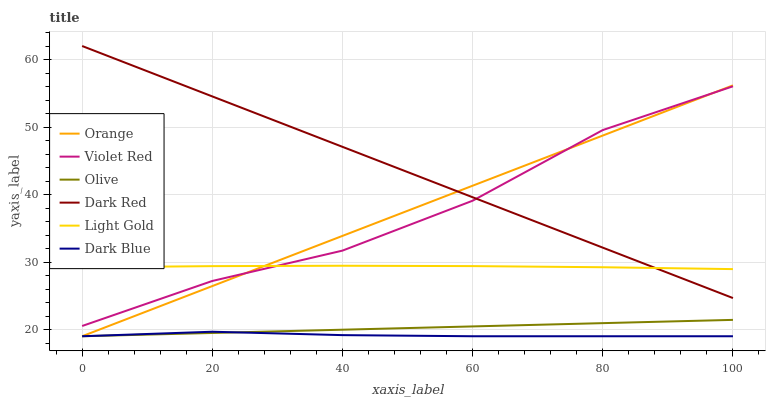Does Dark Blue have the minimum area under the curve?
Answer yes or no. Yes. Does Dark Red have the maximum area under the curve?
Answer yes or no. Yes. Does Dark Red have the minimum area under the curve?
Answer yes or no. No. Does Dark Blue have the maximum area under the curve?
Answer yes or no. No. Is Olive the smoothest?
Answer yes or no. Yes. Is Violet Red the roughest?
Answer yes or no. Yes. Is Dark Blue the smoothest?
Answer yes or no. No. Is Dark Blue the roughest?
Answer yes or no. No. Does Dark Red have the lowest value?
Answer yes or no. No. Does Dark Blue have the highest value?
Answer yes or no. No. Is Olive less than Violet Red?
Answer yes or no. Yes. Is Light Gold greater than Dark Blue?
Answer yes or no. Yes. Does Olive intersect Violet Red?
Answer yes or no. No. 